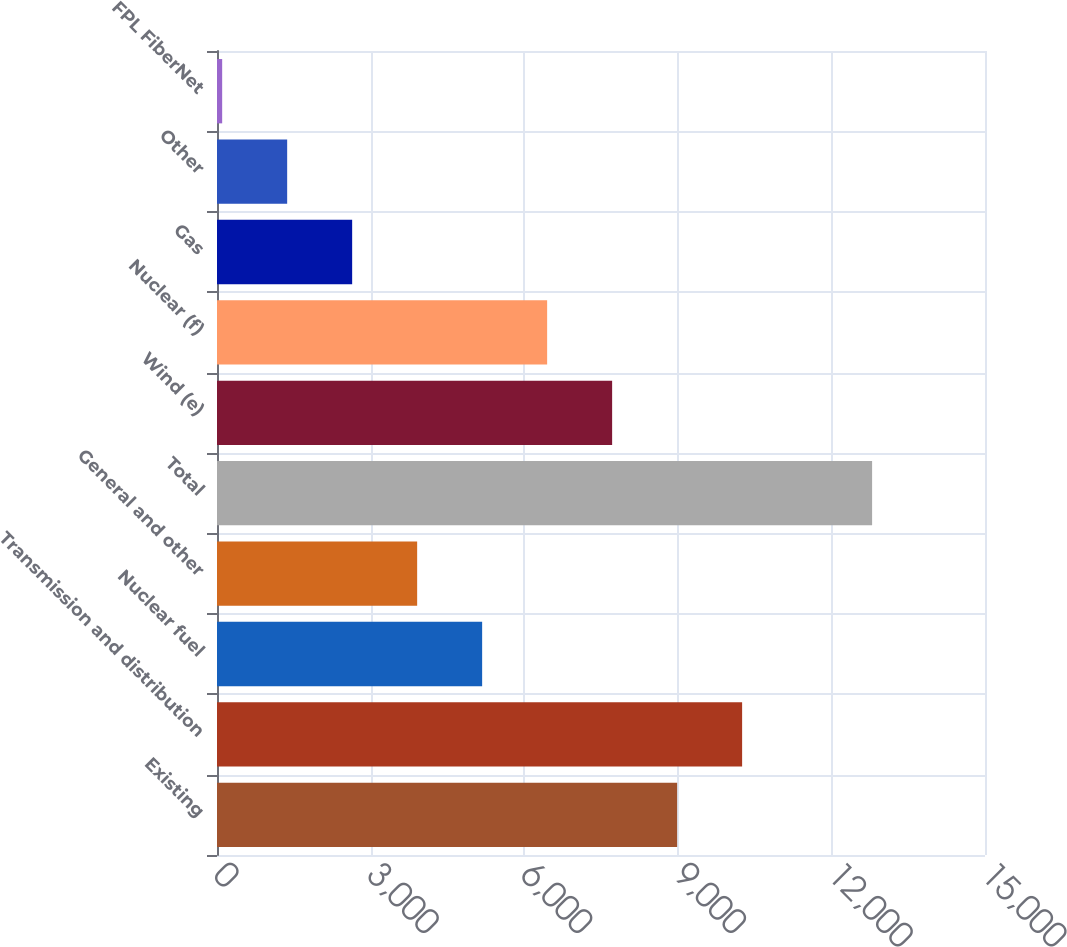Convert chart to OTSL. <chart><loc_0><loc_0><loc_500><loc_500><bar_chart><fcel>Existing<fcel>Transmission and distribution<fcel>Nuclear fuel<fcel>General and other<fcel>Total<fcel>Wind (e)<fcel>Nuclear (f)<fcel>Gas<fcel>Other<fcel>FPL FiberNet<nl><fcel>8986.8<fcel>10256.2<fcel>5178.6<fcel>3909.2<fcel>12795<fcel>7717.4<fcel>6448<fcel>2639.8<fcel>1370.4<fcel>101<nl></chart> 